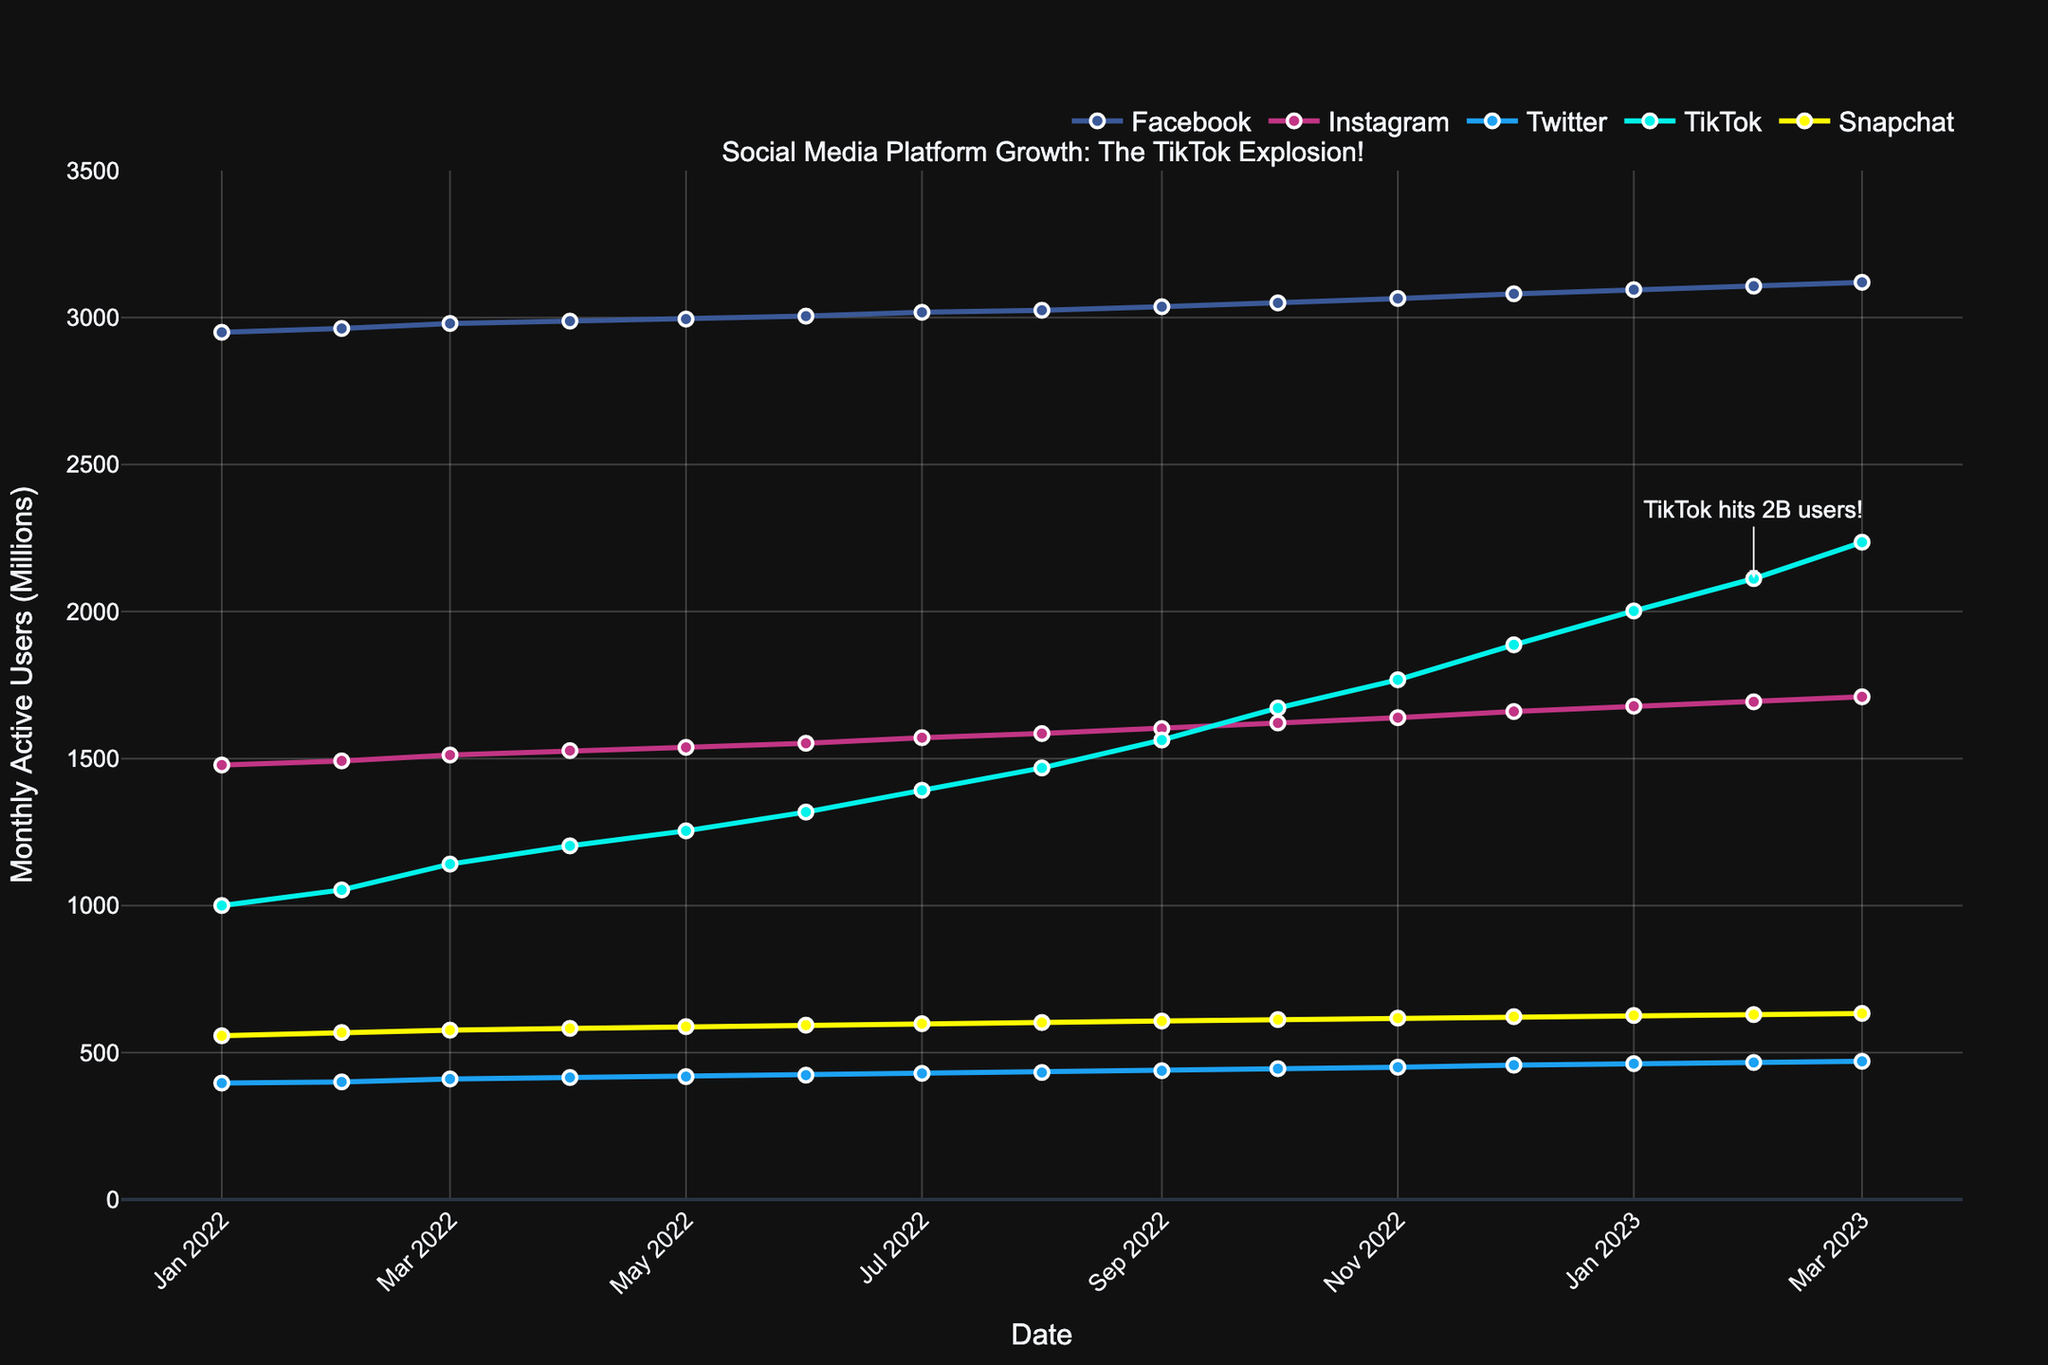Which social media platform showed the most significant growth from January 2022 to March 2023? First, note the user counts for each platform in January 2022 and March 2023. Then, calculate the difference for each platform.
Facebook: 3120 - 2950 = 170 million users
Instagram: 1710 - 1478 = 232 million users
Twitter: 470 - 396 = 74 million users
TikTok: 2236 - 1000 = 1236 million users
Snapchat: 633 - 557 = 76 million users
The platform with the highest difference is TikTok.
Answer: TikTok In what month did TikTok surpass Twitter in terms of monthly active users? Look for the annotation on the chart indicating TikTok surpassing Twitter. It is marked around August 2022.
Answer: August 2022 Between which two months did TikTok see its highest increase in monthly active users? Compare the month-by-month increase in TikTok users across the provided timeline. The biggest jump appears between January 2023 (2002 million) and February 2023 (2112 million), showing a 110 million user increase.
Answer: January 2023 to February 2023 How many months did it take for TikTok to go from 1 billion to 2 billion users? Identify when TikTok hit 1 billion users (January 2022) and when it hit 2 billion users (January 2023). Count the number of months between these two points (inclusive).
Answer: 13 months Which platform had the slowest growth rate over the observed period? Calculate the total growth for each platform as done earlier. The platform with the smallest difference in users from January 2022 to March 2023 is Twitter with 74 million.
Answer: Twitter What is the average number of Snapchat users in 2023 (up to March)? Add the number of Snapchat users for January, February, and March 2023, then divide by 3.
(626 + 629 + 633) / 3 = 1888 / 3 = 629.33 million users
Answer: 629.33 million users When did TikTok hit 2 billion monthly active users? The chart has an annotation mentioning "TikTok hits 2B users" around February 2023.
Answer: February 2023 Which social media platform experienced a noticeable spike in user growth in the latter half of 2022? Observe the trajectory of each line in the latter half of 2022. TikTok shows a noticeable upward spike from August 2022 onwards.
Answer: TikTok Compare the growth rate of Facebook and Instagram from January 2022 to March 2023. Which platform grew faster? Calculate the growth for both platforms from January 2022 to March 2023.
Facebook: 3120 - 2950 = 170 million users
Instagram: 1710 - 1478 = 232 million users
Instagram has a higher growth rate.
Answer: Instagram 